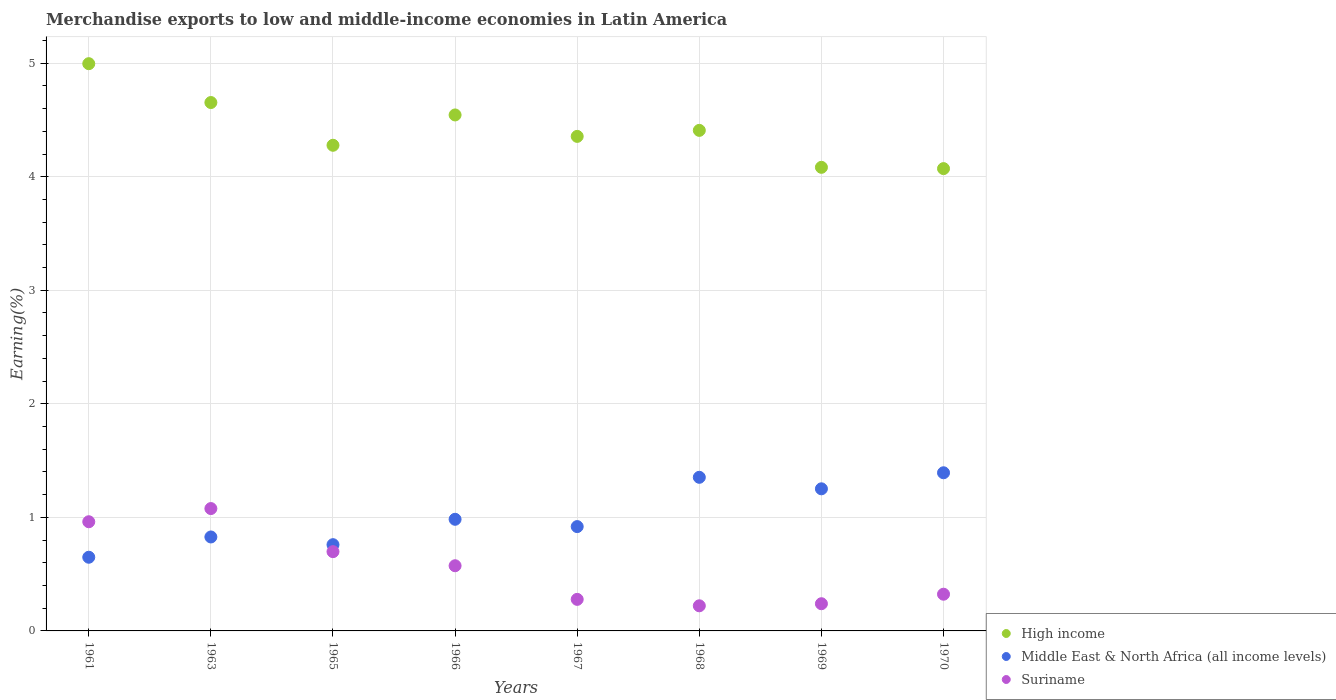How many different coloured dotlines are there?
Provide a succinct answer. 3. Is the number of dotlines equal to the number of legend labels?
Provide a short and direct response. Yes. What is the percentage of amount earned from merchandise exports in Suriname in 1967?
Provide a succinct answer. 0.28. Across all years, what is the maximum percentage of amount earned from merchandise exports in High income?
Give a very brief answer. 5. Across all years, what is the minimum percentage of amount earned from merchandise exports in Middle East & North Africa (all income levels)?
Offer a terse response. 0.65. In which year was the percentage of amount earned from merchandise exports in Suriname minimum?
Give a very brief answer. 1968. What is the total percentage of amount earned from merchandise exports in Suriname in the graph?
Ensure brevity in your answer.  4.37. What is the difference between the percentage of amount earned from merchandise exports in Suriname in 1967 and that in 1970?
Provide a short and direct response. -0.05. What is the difference between the percentage of amount earned from merchandise exports in Middle East & North Africa (all income levels) in 1967 and the percentage of amount earned from merchandise exports in Suriname in 1963?
Give a very brief answer. -0.16. What is the average percentage of amount earned from merchandise exports in Suriname per year?
Offer a terse response. 0.55. In the year 1968, what is the difference between the percentage of amount earned from merchandise exports in Suriname and percentage of amount earned from merchandise exports in Middle East & North Africa (all income levels)?
Your answer should be very brief. -1.13. In how many years, is the percentage of amount earned from merchandise exports in Middle East & North Africa (all income levels) greater than 2.4 %?
Provide a succinct answer. 0. What is the ratio of the percentage of amount earned from merchandise exports in High income in 1963 to that in 1966?
Your answer should be very brief. 1.02. What is the difference between the highest and the second highest percentage of amount earned from merchandise exports in Middle East & North Africa (all income levels)?
Your answer should be compact. 0.04. What is the difference between the highest and the lowest percentage of amount earned from merchandise exports in Suriname?
Your response must be concise. 0.86. Is the sum of the percentage of amount earned from merchandise exports in Middle East & North Africa (all income levels) in 1965 and 1970 greater than the maximum percentage of amount earned from merchandise exports in Suriname across all years?
Your response must be concise. Yes. Are the values on the major ticks of Y-axis written in scientific E-notation?
Provide a short and direct response. No. Does the graph contain grids?
Make the answer very short. Yes. Where does the legend appear in the graph?
Your response must be concise. Bottom right. How many legend labels are there?
Ensure brevity in your answer.  3. How are the legend labels stacked?
Your answer should be very brief. Vertical. What is the title of the graph?
Your answer should be compact. Merchandise exports to low and middle-income economies in Latin America. Does "Monaco" appear as one of the legend labels in the graph?
Provide a succinct answer. No. What is the label or title of the Y-axis?
Ensure brevity in your answer.  Earning(%). What is the Earning(%) of High income in 1961?
Provide a succinct answer. 5. What is the Earning(%) in Middle East & North Africa (all income levels) in 1961?
Provide a succinct answer. 0.65. What is the Earning(%) in Suriname in 1961?
Offer a terse response. 0.96. What is the Earning(%) of High income in 1963?
Offer a very short reply. 4.65. What is the Earning(%) in Middle East & North Africa (all income levels) in 1963?
Provide a succinct answer. 0.83. What is the Earning(%) in Suriname in 1963?
Your response must be concise. 1.08. What is the Earning(%) of High income in 1965?
Ensure brevity in your answer.  4.28. What is the Earning(%) in Middle East & North Africa (all income levels) in 1965?
Offer a very short reply. 0.76. What is the Earning(%) of Suriname in 1965?
Your response must be concise. 0.7. What is the Earning(%) of High income in 1966?
Make the answer very short. 4.54. What is the Earning(%) of Middle East & North Africa (all income levels) in 1966?
Keep it short and to the point. 0.98. What is the Earning(%) in Suriname in 1966?
Keep it short and to the point. 0.57. What is the Earning(%) in High income in 1967?
Offer a terse response. 4.36. What is the Earning(%) in Middle East & North Africa (all income levels) in 1967?
Your response must be concise. 0.92. What is the Earning(%) in Suriname in 1967?
Your answer should be very brief. 0.28. What is the Earning(%) of High income in 1968?
Your response must be concise. 4.41. What is the Earning(%) of Middle East & North Africa (all income levels) in 1968?
Give a very brief answer. 1.35. What is the Earning(%) in Suriname in 1968?
Keep it short and to the point. 0.22. What is the Earning(%) of High income in 1969?
Provide a succinct answer. 4.08. What is the Earning(%) in Middle East & North Africa (all income levels) in 1969?
Ensure brevity in your answer.  1.25. What is the Earning(%) of Suriname in 1969?
Make the answer very short. 0.24. What is the Earning(%) of High income in 1970?
Keep it short and to the point. 4.07. What is the Earning(%) in Middle East & North Africa (all income levels) in 1970?
Your answer should be compact. 1.39. What is the Earning(%) in Suriname in 1970?
Your response must be concise. 0.32. Across all years, what is the maximum Earning(%) in High income?
Your answer should be compact. 5. Across all years, what is the maximum Earning(%) of Middle East & North Africa (all income levels)?
Your response must be concise. 1.39. Across all years, what is the maximum Earning(%) in Suriname?
Your answer should be compact. 1.08. Across all years, what is the minimum Earning(%) of High income?
Offer a terse response. 4.07. Across all years, what is the minimum Earning(%) in Middle East & North Africa (all income levels)?
Give a very brief answer. 0.65. Across all years, what is the minimum Earning(%) of Suriname?
Offer a terse response. 0.22. What is the total Earning(%) in High income in the graph?
Offer a terse response. 35.39. What is the total Earning(%) in Middle East & North Africa (all income levels) in the graph?
Your answer should be compact. 8.14. What is the total Earning(%) of Suriname in the graph?
Keep it short and to the point. 4.37. What is the difference between the Earning(%) in High income in 1961 and that in 1963?
Offer a terse response. 0.34. What is the difference between the Earning(%) of Middle East & North Africa (all income levels) in 1961 and that in 1963?
Give a very brief answer. -0.18. What is the difference between the Earning(%) in Suriname in 1961 and that in 1963?
Your answer should be very brief. -0.12. What is the difference between the Earning(%) in High income in 1961 and that in 1965?
Make the answer very short. 0.72. What is the difference between the Earning(%) in Middle East & North Africa (all income levels) in 1961 and that in 1965?
Provide a short and direct response. -0.11. What is the difference between the Earning(%) in Suriname in 1961 and that in 1965?
Provide a succinct answer. 0.26. What is the difference between the Earning(%) in High income in 1961 and that in 1966?
Your answer should be very brief. 0.45. What is the difference between the Earning(%) in Middle East & North Africa (all income levels) in 1961 and that in 1966?
Offer a terse response. -0.33. What is the difference between the Earning(%) in Suriname in 1961 and that in 1966?
Offer a terse response. 0.39. What is the difference between the Earning(%) of High income in 1961 and that in 1967?
Give a very brief answer. 0.64. What is the difference between the Earning(%) in Middle East & North Africa (all income levels) in 1961 and that in 1967?
Provide a short and direct response. -0.27. What is the difference between the Earning(%) in Suriname in 1961 and that in 1967?
Provide a succinct answer. 0.68. What is the difference between the Earning(%) in High income in 1961 and that in 1968?
Your answer should be very brief. 0.59. What is the difference between the Earning(%) of Middle East & North Africa (all income levels) in 1961 and that in 1968?
Keep it short and to the point. -0.7. What is the difference between the Earning(%) in Suriname in 1961 and that in 1968?
Your answer should be very brief. 0.74. What is the difference between the Earning(%) of High income in 1961 and that in 1969?
Your response must be concise. 0.91. What is the difference between the Earning(%) in Middle East & North Africa (all income levels) in 1961 and that in 1969?
Your answer should be very brief. -0.6. What is the difference between the Earning(%) in Suriname in 1961 and that in 1969?
Offer a very short reply. 0.72. What is the difference between the Earning(%) of High income in 1961 and that in 1970?
Offer a very short reply. 0.92. What is the difference between the Earning(%) in Middle East & North Africa (all income levels) in 1961 and that in 1970?
Your answer should be compact. -0.74. What is the difference between the Earning(%) in Suriname in 1961 and that in 1970?
Offer a very short reply. 0.64. What is the difference between the Earning(%) in High income in 1963 and that in 1965?
Your response must be concise. 0.38. What is the difference between the Earning(%) of Middle East & North Africa (all income levels) in 1963 and that in 1965?
Make the answer very short. 0.07. What is the difference between the Earning(%) of Suriname in 1963 and that in 1965?
Provide a succinct answer. 0.38. What is the difference between the Earning(%) in High income in 1963 and that in 1966?
Give a very brief answer. 0.11. What is the difference between the Earning(%) of Middle East & North Africa (all income levels) in 1963 and that in 1966?
Provide a short and direct response. -0.16. What is the difference between the Earning(%) of Suriname in 1963 and that in 1966?
Offer a very short reply. 0.5. What is the difference between the Earning(%) in High income in 1963 and that in 1967?
Your answer should be compact. 0.3. What is the difference between the Earning(%) in Middle East & North Africa (all income levels) in 1963 and that in 1967?
Offer a very short reply. -0.09. What is the difference between the Earning(%) in Suriname in 1963 and that in 1967?
Provide a short and direct response. 0.8. What is the difference between the Earning(%) in High income in 1963 and that in 1968?
Your answer should be very brief. 0.25. What is the difference between the Earning(%) in Middle East & North Africa (all income levels) in 1963 and that in 1968?
Your answer should be compact. -0.53. What is the difference between the Earning(%) in Suriname in 1963 and that in 1968?
Ensure brevity in your answer.  0.86. What is the difference between the Earning(%) in High income in 1963 and that in 1969?
Give a very brief answer. 0.57. What is the difference between the Earning(%) in Middle East & North Africa (all income levels) in 1963 and that in 1969?
Offer a very short reply. -0.42. What is the difference between the Earning(%) of Suriname in 1963 and that in 1969?
Provide a short and direct response. 0.84. What is the difference between the Earning(%) in High income in 1963 and that in 1970?
Offer a very short reply. 0.58. What is the difference between the Earning(%) of Middle East & North Africa (all income levels) in 1963 and that in 1970?
Offer a terse response. -0.57. What is the difference between the Earning(%) of Suriname in 1963 and that in 1970?
Provide a short and direct response. 0.75. What is the difference between the Earning(%) of High income in 1965 and that in 1966?
Offer a very short reply. -0.27. What is the difference between the Earning(%) in Middle East & North Africa (all income levels) in 1965 and that in 1966?
Keep it short and to the point. -0.22. What is the difference between the Earning(%) of Suriname in 1965 and that in 1966?
Your response must be concise. 0.12. What is the difference between the Earning(%) of High income in 1965 and that in 1967?
Give a very brief answer. -0.08. What is the difference between the Earning(%) of Middle East & North Africa (all income levels) in 1965 and that in 1967?
Your response must be concise. -0.16. What is the difference between the Earning(%) of Suriname in 1965 and that in 1967?
Your response must be concise. 0.42. What is the difference between the Earning(%) of High income in 1965 and that in 1968?
Your answer should be compact. -0.13. What is the difference between the Earning(%) in Middle East & North Africa (all income levels) in 1965 and that in 1968?
Your response must be concise. -0.59. What is the difference between the Earning(%) in Suriname in 1965 and that in 1968?
Offer a very short reply. 0.48. What is the difference between the Earning(%) in High income in 1965 and that in 1969?
Give a very brief answer. 0.19. What is the difference between the Earning(%) of Middle East & North Africa (all income levels) in 1965 and that in 1969?
Provide a short and direct response. -0.49. What is the difference between the Earning(%) of Suriname in 1965 and that in 1969?
Offer a very short reply. 0.46. What is the difference between the Earning(%) in High income in 1965 and that in 1970?
Keep it short and to the point. 0.21. What is the difference between the Earning(%) in Middle East & North Africa (all income levels) in 1965 and that in 1970?
Offer a terse response. -0.63. What is the difference between the Earning(%) of Suriname in 1965 and that in 1970?
Offer a terse response. 0.37. What is the difference between the Earning(%) of High income in 1966 and that in 1967?
Ensure brevity in your answer.  0.19. What is the difference between the Earning(%) in Middle East & North Africa (all income levels) in 1966 and that in 1967?
Make the answer very short. 0.06. What is the difference between the Earning(%) in Suriname in 1966 and that in 1967?
Keep it short and to the point. 0.3. What is the difference between the Earning(%) of High income in 1966 and that in 1968?
Give a very brief answer. 0.14. What is the difference between the Earning(%) in Middle East & North Africa (all income levels) in 1966 and that in 1968?
Keep it short and to the point. -0.37. What is the difference between the Earning(%) of Suriname in 1966 and that in 1968?
Provide a succinct answer. 0.35. What is the difference between the Earning(%) of High income in 1966 and that in 1969?
Offer a very short reply. 0.46. What is the difference between the Earning(%) of Middle East & North Africa (all income levels) in 1966 and that in 1969?
Give a very brief answer. -0.27. What is the difference between the Earning(%) of Suriname in 1966 and that in 1969?
Provide a succinct answer. 0.33. What is the difference between the Earning(%) of High income in 1966 and that in 1970?
Offer a very short reply. 0.47. What is the difference between the Earning(%) in Middle East & North Africa (all income levels) in 1966 and that in 1970?
Give a very brief answer. -0.41. What is the difference between the Earning(%) of Suriname in 1966 and that in 1970?
Provide a short and direct response. 0.25. What is the difference between the Earning(%) in High income in 1967 and that in 1968?
Ensure brevity in your answer.  -0.05. What is the difference between the Earning(%) in Middle East & North Africa (all income levels) in 1967 and that in 1968?
Give a very brief answer. -0.43. What is the difference between the Earning(%) in Suriname in 1967 and that in 1968?
Keep it short and to the point. 0.06. What is the difference between the Earning(%) in High income in 1967 and that in 1969?
Ensure brevity in your answer.  0.27. What is the difference between the Earning(%) of Middle East & North Africa (all income levels) in 1967 and that in 1969?
Your response must be concise. -0.33. What is the difference between the Earning(%) in Suriname in 1967 and that in 1969?
Make the answer very short. 0.04. What is the difference between the Earning(%) of High income in 1967 and that in 1970?
Ensure brevity in your answer.  0.28. What is the difference between the Earning(%) in Middle East & North Africa (all income levels) in 1967 and that in 1970?
Your answer should be very brief. -0.47. What is the difference between the Earning(%) of Suriname in 1967 and that in 1970?
Offer a very short reply. -0.05. What is the difference between the Earning(%) of High income in 1968 and that in 1969?
Make the answer very short. 0.33. What is the difference between the Earning(%) in Middle East & North Africa (all income levels) in 1968 and that in 1969?
Your response must be concise. 0.1. What is the difference between the Earning(%) in Suriname in 1968 and that in 1969?
Keep it short and to the point. -0.02. What is the difference between the Earning(%) in High income in 1968 and that in 1970?
Your response must be concise. 0.34. What is the difference between the Earning(%) in Middle East & North Africa (all income levels) in 1968 and that in 1970?
Provide a succinct answer. -0.04. What is the difference between the Earning(%) of Suriname in 1968 and that in 1970?
Your answer should be very brief. -0.1. What is the difference between the Earning(%) of High income in 1969 and that in 1970?
Give a very brief answer. 0.01. What is the difference between the Earning(%) in Middle East & North Africa (all income levels) in 1969 and that in 1970?
Keep it short and to the point. -0.14. What is the difference between the Earning(%) in Suriname in 1969 and that in 1970?
Offer a terse response. -0.08. What is the difference between the Earning(%) of High income in 1961 and the Earning(%) of Middle East & North Africa (all income levels) in 1963?
Provide a succinct answer. 4.17. What is the difference between the Earning(%) in High income in 1961 and the Earning(%) in Suriname in 1963?
Your response must be concise. 3.92. What is the difference between the Earning(%) of Middle East & North Africa (all income levels) in 1961 and the Earning(%) of Suriname in 1963?
Ensure brevity in your answer.  -0.43. What is the difference between the Earning(%) in High income in 1961 and the Earning(%) in Middle East & North Africa (all income levels) in 1965?
Ensure brevity in your answer.  4.24. What is the difference between the Earning(%) in High income in 1961 and the Earning(%) in Suriname in 1965?
Your answer should be very brief. 4.3. What is the difference between the Earning(%) in Middle East & North Africa (all income levels) in 1961 and the Earning(%) in Suriname in 1965?
Your response must be concise. -0.05. What is the difference between the Earning(%) of High income in 1961 and the Earning(%) of Middle East & North Africa (all income levels) in 1966?
Ensure brevity in your answer.  4.01. What is the difference between the Earning(%) of High income in 1961 and the Earning(%) of Suriname in 1966?
Offer a terse response. 4.42. What is the difference between the Earning(%) in Middle East & North Africa (all income levels) in 1961 and the Earning(%) in Suriname in 1966?
Provide a succinct answer. 0.07. What is the difference between the Earning(%) in High income in 1961 and the Earning(%) in Middle East & North Africa (all income levels) in 1967?
Keep it short and to the point. 4.08. What is the difference between the Earning(%) in High income in 1961 and the Earning(%) in Suriname in 1967?
Keep it short and to the point. 4.72. What is the difference between the Earning(%) in Middle East & North Africa (all income levels) in 1961 and the Earning(%) in Suriname in 1967?
Keep it short and to the point. 0.37. What is the difference between the Earning(%) of High income in 1961 and the Earning(%) of Middle East & North Africa (all income levels) in 1968?
Offer a terse response. 3.64. What is the difference between the Earning(%) of High income in 1961 and the Earning(%) of Suriname in 1968?
Offer a terse response. 4.77. What is the difference between the Earning(%) in Middle East & North Africa (all income levels) in 1961 and the Earning(%) in Suriname in 1968?
Offer a very short reply. 0.43. What is the difference between the Earning(%) in High income in 1961 and the Earning(%) in Middle East & North Africa (all income levels) in 1969?
Your answer should be compact. 3.74. What is the difference between the Earning(%) in High income in 1961 and the Earning(%) in Suriname in 1969?
Your response must be concise. 4.76. What is the difference between the Earning(%) in Middle East & North Africa (all income levels) in 1961 and the Earning(%) in Suriname in 1969?
Provide a succinct answer. 0.41. What is the difference between the Earning(%) of High income in 1961 and the Earning(%) of Middle East & North Africa (all income levels) in 1970?
Provide a short and direct response. 3.6. What is the difference between the Earning(%) in High income in 1961 and the Earning(%) in Suriname in 1970?
Keep it short and to the point. 4.67. What is the difference between the Earning(%) of Middle East & North Africa (all income levels) in 1961 and the Earning(%) of Suriname in 1970?
Provide a short and direct response. 0.33. What is the difference between the Earning(%) in High income in 1963 and the Earning(%) in Middle East & North Africa (all income levels) in 1965?
Make the answer very short. 3.89. What is the difference between the Earning(%) in High income in 1963 and the Earning(%) in Suriname in 1965?
Make the answer very short. 3.96. What is the difference between the Earning(%) in Middle East & North Africa (all income levels) in 1963 and the Earning(%) in Suriname in 1965?
Your response must be concise. 0.13. What is the difference between the Earning(%) in High income in 1963 and the Earning(%) in Middle East & North Africa (all income levels) in 1966?
Ensure brevity in your answer.  3.67. What is the difference between the Earning(%) of High income in 1963 and the Earning(%) of Suriname in 1966?
Offer a terse response. 4.08. What is the difference between the Earning(%) of Middle East & North Africa (all income levels) in 1963 and the Earning(%) of Suriname in 1966?
Provide a succinct answer. 0.25. What is the difference between the Earning(%) in High income in 1963 and the Earning(%) in Middle East & North Africa (all income levels) in 1967?
Your response must be concise. 3.73. What is the difference between the Earning(%) in High income in 1963 and the Earning(%) in Suriname in 1967?
Provide a short and direct response. 4.38. What is the difference between the Earning(%) of Middle East & North Africa (all income levels) in 1963 and the Earning(%) of Suriname in 1967?
Make the answer very short. 0.55. What is the difference between the Earning(%) in High income in 1963 and the Earning(%) in Middle East & North Africa (all income levels) in 1968?
Make the answer very short. 3.3. What is the difference between the Earning(%) in High income in 1963 and the Earning(%) in Suriname in 1968?
Ensure brevity in your answer.  4.43. What is the difference between the Earning(%) in Middle East & North Africa (all income levels) in 1963 and the Earning(%) in Suriname in 1968?
Your response must be concise. 0.61. What is the difference between the Earning(%) in High income in 1963 and the Earning(%) in Middle East & North Africa (all income levels) in 1969?
Offer a very short reply. 3.4. What is the difference between the Earning(%) in High income in 1963 and the Earning(%) in Suriname in 1969?
Ensure brevity in your answer.  4.41. What is the difference between the Earning(%) of Middle East & North Africa (all income levels) in 1963 and the Earning(%) of Suriname in 1969?
Make the answer very short. 0.59. What is the difference between the Earning(%) of High income in 1963 and the Earning(%) of Middle East & North Africa (all income levels) in 1970?
Ensure brevity in your answer.  3.26. What is the difference between the Earning(%) of High income in 1963 and the Earning(%) of Suriname in 1970?
Provide a succinct answer. 4.33. What is the difference between the Earning(%) in Middle East & North Africa (all income levels) in 1963 and the Earning(%) in Suriname in 1970?
Offer a very short reply. 0.5. What is the difference between the Earning(%) in High income in 1965 and the Earning(%) in Middle East & North Africa (all income levels) in 1966?
Provide a short and direct response. 3.29. What is the difference between the Earning(%) of High income in 1965 and the Earning(%) of Suriname in 1966?
Provide a short and direct response. 3.7. What is the difference between the Earning(%) of Middle East & North Africa (all income levels) in 1965 and the Earning(%) of Suriname in 1966?
Keep it short and to the point. 0.19. What is the difference between the Earning(%) in High income in 1965 and the Earning(%) in Middle East & North Africa (all income levels) in 1967?
Your answer should be very brief. 3.36. What is the difference between the Earning(%) in High income in 1965 and the Earning(%) in Suriname in 1967?
Ensure brevity in your answer.  4. What is the difference between the Earning(%) of Middle East & North Africa (all income levels) in 1965 and the Earning(%) of Suriname in 1967?
Provide a succinct answer. 0.48. What is the difference between the Earning(%) in High income in 1965 and the Earning(%) in Middle East & North Africa (all income levels) in 1968?
Your answer should be very brief. 2.92. What is the difference between the Earning(%) in High income in 1965 and the Earning(%) in Suriname in 1968?
Your answer should be very brief. 4.06. What is the difference between the Earning(%) in Middle East & North Africa (all income levels) in 1965 and the Earning(%) in Suriname in 1968?
Provide a short and direct response. 0.54. What is the difference between the Earning(%) in High income in 1965 and the Earning(%) in Middle East & North Africa (all income levels) in 1969?
Your response must be concise. 3.03. What is the difference between the Earning(%) of High income in 1965 and the Earning(%) of Suriname in 1969?
Keep it short and to the point. 4.04. What is the difference between the Earning(%) in Middle East & North Africa (all income levels) in 1965 and the Earning(%) in Suriname in 1969?
Offer a very short reply. 0.52. What is the difference between the Earning(%) in High income in 1965 and the Earning(%) in Middle East & North Africa (all income levels) in 1970?
Offer a very short reply. 2.88. What is the difference between the Earning(%) of High income in 1965 and the Earning(%) of Suriname in 1970?
Offer a very short reply. 3.95. What is the difference between the Earning(%) in Middle East & North Africa (all income levels) in 1965 and the Earning(%) in Suriname in 1970?
Keep it short and to the point. 0.44. What is the difference between the Earning(%) in High income in 1966 and the Earning(%) in Middle East & North Africa (all income levels) in 1967?
Your answer should be very brief. 3.63. What is the difference between the Earning(%) of High income in 1966 and the Earning(%) of Suriname in 1967?
Your answer should be compact. 4.27. What is the difference between the Earning(%) in Middle East & North Africa (all income levels) in 1966 and the Earning(%) in Suriname in 1967?
Offer a very short reply. 0.71. What is the difference between the Earning(%) in High income in 1966 and the Earning(%) in Middle East & North Africa (all income levels) in 1968?
Your answer should be compact. 3.19. What is the difference between the Earning(%) of High income in 1966 and the Earning(%) of Suriname in 1968?
Provide a succinct answer. 4.32. What is the difference between the Earning(%) in Middle East & North Africa (all income levels) in 1966 and the Earning(%) in Suriname in 1968?
Provide a short and direct response. 0.76. What is the difference between the Earning(%) of High income in 1966 and the Earning(%) of Middle East & North Africa (all income levels) in 1969?
Offer a terse response. 3.29. What is the difference between the Earning(%) in High income in 1966 and the Earning(%) in Suriname in 1969?
Provide a short and direct response. 4.3. What is the difference between the Earning(%) in Middle East & North Africa (all income levels) in 1966 and the Earning(%) in Suriname in 1969?
Keep it short and to the point. 0.74. What is the difference between the Earning(%) in High income in 1966 and the Earning(%) in Middle East & North Africa (all income levels) in 1970?
Your response must be concise. 3.15. What is the difference between the Earning(%) in High income in 1966 and the Earning(%) in Suriname in 1970?
Make the answer very short. 4.22. What is the difference between the Earning(%) in Middle East & North Africa (all income levels) in 1966 and the Earning(%) in Suriname in 1970?
Keep it short and to the point. 0.66. What is the difference between the Earning(%) of High income in 1967 and the Earning(%) of Middle East & North Africa (all income levels) in 1968?
Provide a succinct answer. 3. What is the difference between the Earning(%) in High income in 1967 and the Earning(%) in Suriname in 1968?
Keep it short and to the point. 4.13. What is the difference between the Earning(%) in Middle East & North Africa (all income levels) in 1967 and the Earning(%) in Suriname in 1968?
Offer a terse response. 0.7. What is the difference between the Earning(%) in High income in 1967 and the Earning(%) in Middle East & North Africa (all income levels) in 1969?
Provide a succinct answer. 3.1. What is the difference between the Earning(%) in High income in 1967 and the Earning(%) in Suriname in 1969?
Give a very brief answer. 4.12. What is the difference between the Earning(%) of Middle East & North Africa (all income levels) in 1967 and the Earning(%) of Suriname in 1969?
Ensure brevity in your answer.  0.68. What is the difference between the Earning(%) of High income in 1967 and the Earning(%) of Middle East & North Africa (all income levels) in 1970?
Make the answer very short. 2.96. What is the difference between the Earning(%) of High income in 1967 and the Earning(%) of Suriname in 1970?
Your response must be concise. 4.03. What is the difference between the Earning(%) of Middle East & North Africa (all income levels) in 1967 and the Earning(%) of Suriname in 1970?
Keep it short and to the point. 0.6. What is the difference between the Earning(%) of High income in 1968 and the Earning(%) of Middle East & North Africa (all income levels) in 1969?
Offer a terse response. 3.16. What is the difference between the Earning(%) of High income in 1968 and the Earning(%) of Suriname in 1969?
Offer a very short reply. 4.17. What is the difference between the Earning(%) in Middle East & North Africa (all income levels) in 1968 and the Earning(%) in Suriname in 1969?
Your answer should be very brief. 1.11. What is the difference between the Earning(%) of High income in 1968 and the Earning(%) of Middle East & North Africa (all income levels) in 1970?
Offer a terse response. 3.02. What is the difference between the Earning(%) in High income in 1968 and the Earning(%) in Suriname in 1970?
Offer a very short reply. 4.08. What is the difference between the Earning(%) of Middle East & North Africa (all income levels) in 1968 and the Earning(%) of Suriname in 1970?
Provide a short and direct response. 1.03. What is the difference between the Earning(%) in High income in 1969 and the Earning(%) in Middle East & North Africa (all income levels) in 1970?
Make the answer very short. 2.69. What is the difference between the Earning(%) in High income in 1969 and the Earning(%) in Suriname in 1970?
Offer a terse response. 3.76. What is the difference between the Earning(%) of Middle East & North Africa (all income levels) in 1969 and the Earning(%) of Suriname in 1970?
Give a very brief answer. 0.93. What is the average Earning(%) of High income per year?
Your answer should be compact. 4.42. What is the average Earning(%) in Middle East & North Africa (all income levels) per year?
Keep it short and to the point. 1.02. What is the average Earning(%) in Suriname per year?
Keep it short and to the point. 0.55. In the year 1961, what is the difference between the Earning(%) of High income and Earning(%) of Middle East & North Africa (all income levels)?
Ensure brevity in your answer.  4.35. In the year 1961, what is the difference between the Earning(%) in High income and Earning(%) in Suriname?
Provide a short and direct response. 4.03. In the year 1961, what is the difference between the Earning(%) in Middle East & North Africa (all income levels) and Earning(%) in Suriname?
Offer a terse response. -0.31. In the year 1963, what is the difference between the Earning(%) in High income and Earning(%) in Middle East & North Africa (all income levels)?
Provide a short and direct response. 3.83. In the year 1963, what is the difference between the Earning(%) in High income and Earning(%) in Suriname?
Your answer should be very brief. 3.58. In the year 1963, what is the difference between the Earning(%) in Middle East & North Africa (all income levels) and Earning(%) in Suriname?
Keep it short and to the point. -0.25. In the year 1965, what is the difference between the Earning(%) of High income and Earning(%) of Middle East & North Africa (all income levels)?
Offer a very short reply. 3.52. In the year 1965, what is the difference between the Earning(%) in High income and Earning(%) in Suriname?
Make the answer very short. 3.58. In the year 1965, what is the difference between the Earning(%) of Middle East & North Africa (all income levels) and Earning(%) of Suriname?
Give a very brief answer. 0.06. In the year 1966, what is the difference between the Earning(%) in High income and Earning(%) in Middle East & North Africa (all income levels)?
Your response must be concise. 3.56. In the year 1966, what is the difference between the Earning(%) of High income and Earning(%) of Suriname?
Your answer should be very brief. 3.97. In the year 1966, what is the difference between the Earning(%) of Middle East & North Africa (all income levels) and Earning(%) of Suriname?
Offer a terse response. 0.41. In the year 1967, what is the difference between the Earning(%) of High income and Earning(%) of Middle East & North Africa (all income levels)?
Keep it short and to the point. 3.44. In the year 1967, what is the difference between the Earning(%) of High income and Earning(%) of Suriname?
Provide a succinct answer. 4.08. In the year 1967, what is the difference between the Earning(%) of Middle East & North Africa (all income levels) and Earning(%) of Suriname?
Provide a succinct answer. 0.64. In the year 1968, what is the difference between the Earning(%) of High income and Earning(%) of Middle East & North Africa (all income levels)?
Provide a succinct answer. 3.06. In the year 1968, what is the difference between the Earning(%) of High income and Earning(%) of Suriname?
Provide a short and direct response. 4.19. In the year 1968, what is the difference between the Earning(%) in Middle East & North Africa (all income levels) and Earning(%) in Suriname?
Your response must be concise. 1.13. In the year 1969, what is the difference between the Earning(%) of High income and Earning(%) of Middle East & North Africa (all income levels)?
Make the answer very short. 2.83. In the year 1969, what is the difference between the Earning(%) in High income and Earning(%) in Suriname?
Keep it short and to the point. 3.84. In the year 1970, what is the difference between the Earning(%) of High income and Earning(%) of Middle East & North Africa (all income levels)?
Your response must be concise. 2.68. In the year 1970, what is the difference between the Earning(%) in High income and Earning(%) in Suriname?
Give a very brief answer. 3.75. In the year 1970, what is the difference between the Earning(%) in Middle East & North Africa (all income levels) and Earning(%) in Suriname?
Offer a terse response. 1.07. What is the ratio of the Earning(%) in High income in 1961 to that in 1963?
Give a very brief answer. 1.07. What is the ratio of the Earning(%) of Middle East & North Africa (all income levels) in 1961 to that in 1963?
Offer a terse response. 0.78. What is the ratio of the Earning(%) of Suriname in 1961 to that in 1963?
Make the answer very short. 0.89. What is the ratio of the Earning(%) of High income in 1961 to that in 1965?
Your response must be concise. 1.17. What is the ratio of the Earning(%) of Middle East & North Africa (all income levels) in 1961 to that in 1965?
Your answer should be very brief. 0.85. What is the ratio of the Earning(%) of Suriname in 1961 to that in 1965?
Make the answer very short. 1.38. What is the ratio of the Earning(%) in High income in 1961 to that in 1966?
Give a very brief answer. 1.1. What is the ratio of the Earning(%) in Middle East & North Africa (all income levels) in 1961 to that in 1966?
Ensure brevity in your answer.  0.66. What is the ratio of the Earning(%) in Suriname in 1961 to that in 1966?
Your answer should be very brief. 1.68. What is the ratio of the Earning(%) of High income in 1961 to that in 1967?
Give a very brief answer. 1.15. What is the ratio of the Earning(%) of Middle East & North Africa (all income levels) in 1961 to that in 1967?
Provide a short and direct response. 0.71. What is the ratio of the Earning(%) in Suriname in 1961 to that in 1967?
Keep it short and to the point. 3.46. What is the ratio of the Earning(%) of High income in 1961 to that in 1968?
Make the answer very short. 1.13. What is the ratio of the Earning(%) of Middle East & North Africa (all income levels) in 1961 to that in 1968?
Your response must be concise. 0.48. What is the ratio of the Earning(%) of Suriname in 1961 to that in 1968?
Ensure brevity in your answer.  4.35. What is the ratio of the Earning(%) of High income in 1961 to that in 1969?
Ensure brevity in your answer.  1.22. What is the ratio of the Earning(%) in Middle East & North Africa (all income levels) in 1961 to that in 1969?
Provide a succinct answer. 0.52. What is the ratio of the Earning(%) of Suriname in 1961 to that in 1969?
Provide a succinct answer. 4.01. What is the ratio of the Earning(%) in High income in 1961 to that in 1970?
Make the answer very short. 1.23. What is the ratio of the Earning(%) of Middle East & North Africa (all income levels) in 1961 to that in 1970?
Give a very brief answer. 0.47. What is the ratio of the Earning(%) in Suriname in 1961 to that in 1970?
Offer a terse response. 2.97. What is the ratio of the Earning(%) of High income in 1963 to that in 1965?
Offer a terse response. 1.09. What is the ratio of the Earning(%) of Middle East & North Africa (all income levels) in 1963 to that in 1965?
Your answer should be very brief. 1.09. What is the ratio of the Earning(%) in Suriname in 1963 to that in 1965?
Offer a very short reply. 1.54. What is the ratio of the Earning(%) in Middle East & North Africa (all income levels) in 1963 to that in 1966?
Your response must be concise. 0.84. What is the ratio of the Earning(%) in Suriname in 1963 to that in 1966?
Provide a succinct answer. 1.88. What is the ratio of the Earning(%) in High income in 1963 to that in 1967?
Offer a very short reply. 1.07. What is the ratio of the Earning(%) of Middle East & North Africa (all income levels) in 1963 to that in 1967?
Your response must be concise. 0.9. What is the ratio of the Earning(%) of Suriname in 1963 to that in 1967?
Keep it short and to the point. 3.88. What is the ratio of the Earning(%) of High income in 1963 to that in 1968?
Provide a succinct answer. 1.06. What is the ratio of the Earning(%) in Middle East & North Africa (all income levels) in 1963 to that in 1968?
Provide a short and direct response. 0.61. What is the ratio of the Earning(%) in Suriname in 1963 to that in 1968?
Provide a short and direct response. 4.87. What is the ratio of the Earning(%) in High income in 1963 to that in 1969?
Provide a succinct answer. 1.14. What is the ratio of the Earning(%) in Middle East & North Africa (all income levels) in 1963 to that in 1969?
Give a very brief answer. 0.66. What is the ratio of the Earning(%) of Suriname in 1963 to that in 1969?
Your answer should be very brief. 4.5. What is the ratio of the Earning(%) in High income in 1963 to that in 1970?
Provide a short and direct response. 1.14. What is the ratio of the Earning(%) of Middle East & North Africa (all income levels) in 1963 to that in 1970?
Give a very brief answer. 0.59. What is the ratio of the Earning(%) in Suriname in 1963 to that in 1970?
Provide a short and direct response. 3.33. What is the ratio of the Earning(%) of Middle East & North Africa (all income levels) in 1965 to that in 1966?
Give a very brief answer. 0.77. What is the ratio of the Earning(%) in Suriname in 1965 to that in 1966?
Ensure brevity in your answer.  1.22. What is the ratio of the Earning(%) of Middle East & North Africa (all income levels) in 1965 to that in 1967?
Make the answer very short. 0.83. What is the ratio of the Earning(%) of Suriname in 1965 to that in 1967?
Your answer should be compact. 2.51. What is the ratio of the Earning(%) in High income in 1965 to that in 1968?
Give a very brief answer. 0.97. What is the ratio of the Earning(%) in Middle East & North Africa (all income levels) in 1965 to that in 1968?
Provide a short and direct response. 0.56. What is the ratio of the Earning(%) of Suriname in 1965 to that in 1968?
Offer a very short reply. 3.16. What is the ratio of the Earning(%) in High income in 1965 to that in 1969?
Offer a very short reply. 1.05. What is the ratio of the Earning(%) of Middle East & North Africa (all income levels) in 1965 to that in 1969?
Your response must be concise. 0.61. What is the ratio of the Earning(%) of Suriname in 1965 to that in 1969?
Offer a very short reply. 2.91. What is the ratio of the Earning(%) in High income in 1965 to that in 1970?
Your response must be concise. 1.05. What is the ratio of the Earning(%) in Middle East & North Africa (all income levels) in 1965 to that in 1970?
Give a very brief answer. 0.55. What is the ratio of the Earning(%) of Suriname in 1965 to that in 1970?
Your answer should be compact. 2.16. What is the ratio of the Earning(%) in High income in 1966 to that in 1967?
Offer a very short reply. 1.04. What is the ratio of the Earning(%) in Middle East & North Africa (all income levels) in 1966 to that in 1967?
Offer a very short reply. 1.07. What is the ratio of the Earning(%) in Suriname in 1966 to that in 1967?
Your answer should be very brief. 2.07. What is the ratio of the Earning(%) in High income in 1966 to that in 1968?
Make the answer very short. 1.03. What is the ratio of the Earning(%) of Middle East & North Africa (all income levels) in 1966 to that in 1968?
Provide a short and direct response. 0.73. What is the ratio of the Earning(%) of Suriname in 1966 to that in 1968?
Offer a very short reply. 2.59. What is the ratio of the Earning(%) in High income in 1966 to that in 1969?
Your answer should be very brief. 1.11. What is the ratio of the Earning(%) in Middle East & North Africa (all income levels) in 1966 to that in 1969?
Make the answer very short. 0.79. What is the ratio of the Earning(%) of Suriname in 1966 to that in 1969?
Keep it short and to the point. 2.4. What is the ratio of the Earning(%) of High income in 1966 to that in 1970?
Provide a short and direct response. 1.12. What is the ratio of the Earning(%) in Middle East & North Africa (all income levels) in 1966 to that in 1970?
Keep it short and to the point. 0.71. What is the ratio of the Earning(%) in Suriname in 1966 to that in 1970?
Your answer should be very brief. 1.78. What is the ratio of the Earning(%) of High income in 1967 to that in 1968?
Ensure brevity in your answer.  0.99. What is the ratio of the Earning(%) in Middle East & North Africa (all income levels) in 1967 to that in 1968?
Keep it short and to the point. 0.68. What is the ratio of the Earning(%) in Suriname in 1967 to that in 1968?
Your response must be concise. 1.26. What is the ratio of the Earning(%) in High income in 1967 to that in 1969?
Your response must be concise. 1.07. What is the ratio of the Earning(%) of Middle East & North Africa (all income levels) in 1967 to that in 1969?
Provide a short and direct response. 0.73. What is the ratio of the Earning(%) in Suriname in 1967 to that in 1969?
Your response must be concise. 1.16. What is the ratio of the Earning(%) in High income in 1967 to that in 1970?
Offer a very short reply. 1.07. What is the ratio of the Earning(%) in Middle East & North Africa (all income levels) in 1967 to that in 1970?
Ensure brevity in your answer.  0.66. What is the ratio of the Earning(%) of Suriname in 1967 to that in 1970?
Your response must be concise. 0.86. What is the ratio of the Earning(%) of High income in 1968 to that in 1969?
Offer a terse response. 1.08. What is the ratio of the Earning(%) of Middle East & North Africa (all income levels) in 1968 to that in 1969?
Offer a terse response. 1.08. What is the ratio of the Earning(%) in Suriname in 1968 to that in 1969?
Make the answer very short. 0.92. What is the ratio of the Earning(%) of High income in 1968 to that in 1970?
Your response must be concise. 1.08. What is the ratio of the Earning(%) in Middle East & North Africa (all income levels) in 1968 to that in 1970?
Offer a terse response. 0.97. What is the ratio of the Earning(%) of Suriname in 1968 to that in 1970?
Your answer should be very brief. 0.68. What is the ratio of the Earning(%) of High income in 1969 to that in 1970?
Provide a short and direct response. 1. What is the ratio of the Earning(%) in Middle East & North Africa (all income levels) in 1969 to that in 1970?
Give a very brief answer. 0.9. What is the ratio of the Earning(%) in Suriname in 1969 to that in 1970?
Provide a succinct answer. 0.74. What is the difference between the highest and the second highest Earning(%) in High income?
Your answer should be compact. 0.34. What is the difference between the highest and the second highest Earning(%) in Suriname?
Offer a very short reply. 0.12. What is the difference between the highest and the lowest Earning(%) in High income?
Provide a short and direct response. 0.92. What is the difference between the highest and the lowest Earning(%) of Middle East & North Africa (all income levels)?
Ensure brevity in your answer.  0.74. What is the difference between the highest and the lowest Earning(%) of Suriname?
Offer a terse response. 0.86. 